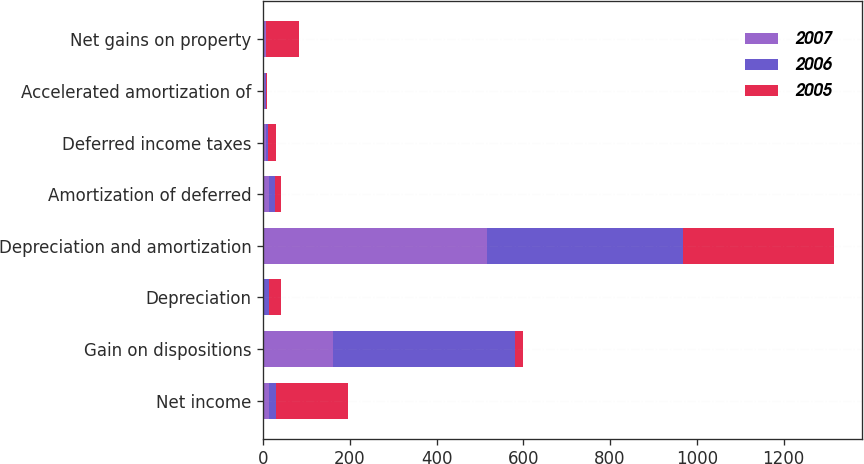Convert chart to OTSL. <chart><loc_0><loc_0><loc_500><loc_500><stacked_bar_chart><ecel><fcel>Net income<fcel>Gain on dispositions<fcel>Depreciation<fcel>Depreciation and amortization<fcel>Amortization of deferred<fcel>Deferred income taxes<fcel>Accelerated amortization of<fcel>Net gains on property<nl><fcel>2007<fcel>14.5<fcel>162<fcel>3<fcel>517<fcel>13<fcel>7<fcel>5<fcel>6<nl><fcel>2006<fcel>14.5<fcel>418<fcel>12<fcel>451<fcel>15<fcel>5<fcel>1<fcel>1<nl><fcel>2005<fcel>166<fcel>19<fcel>26<fcel>347<fcel>14<fcel>17<fcel>3<fcel>75<nl></chart> 